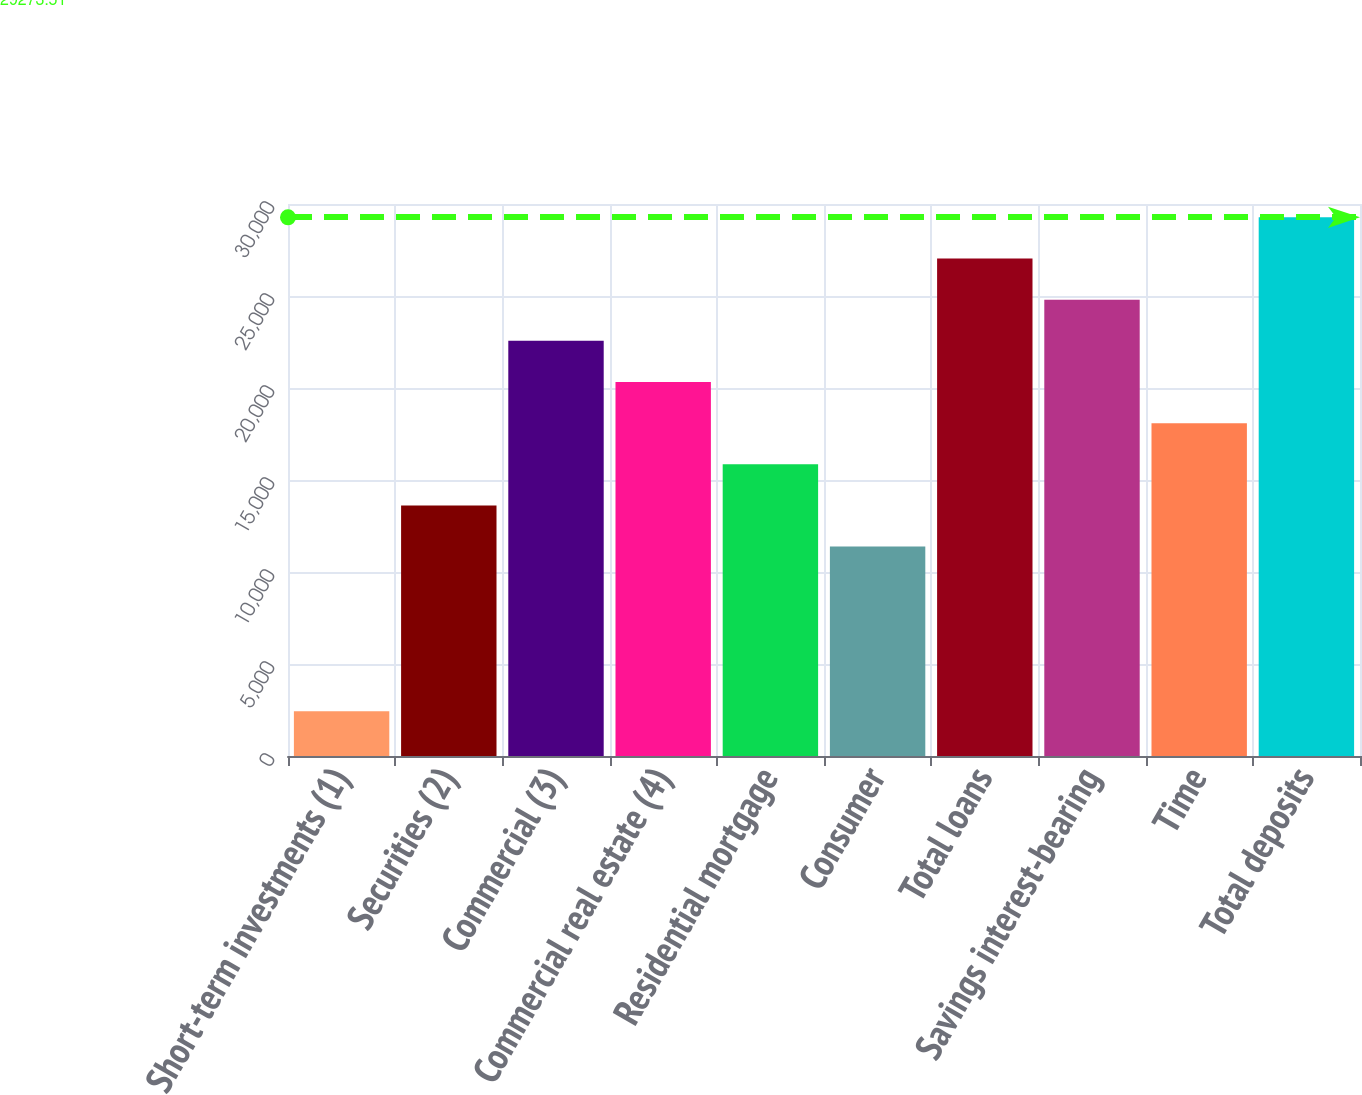Convert chart. <chart><loc_0><loc_0><loc_500><loc_500><bar_chart><fcel>Short-term investments (1)<fcel>Securities (2)<fcel>Commercial (3)<fcel>Commercial real estate (4)<fcel>Residential mortgage<fcel>Consumer<fcel>Total loans<fcel>Savings interest-bearing<fcel>Time<fcel>Total deposits<nl><fcel>2432.27<fcel>13616.1<fcel>22563.2<fcel>20326.4<fcel>15852.9<fcel>11379.4<fcel>27036.7<fcel>24800<fcel>18089.7<fcel>29273.5<nl></chart> 